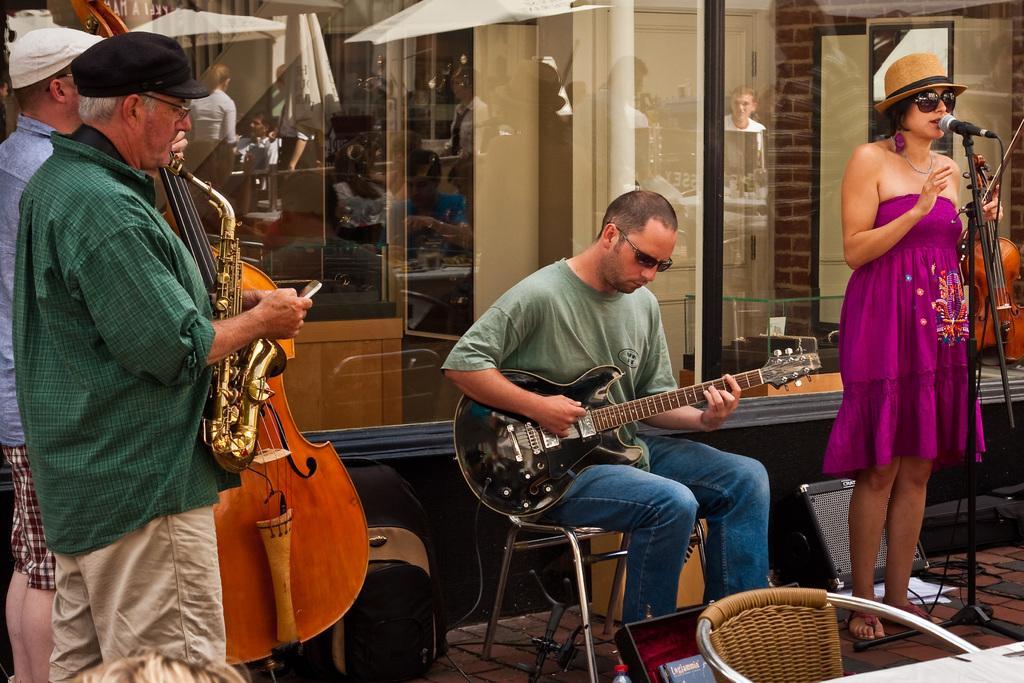Describe this image in one or two sentences. In this picture we can see four persons holding the musical instruments. A man is sitting on a chair. On the right side of the image, there is a microphone with a stand and a cable. On the ground, there are cables, a chair, a backpack and some objects. Behind the people, there is a transparent material. On the transparent material, we can see the reflections of people, a building and some objects. 